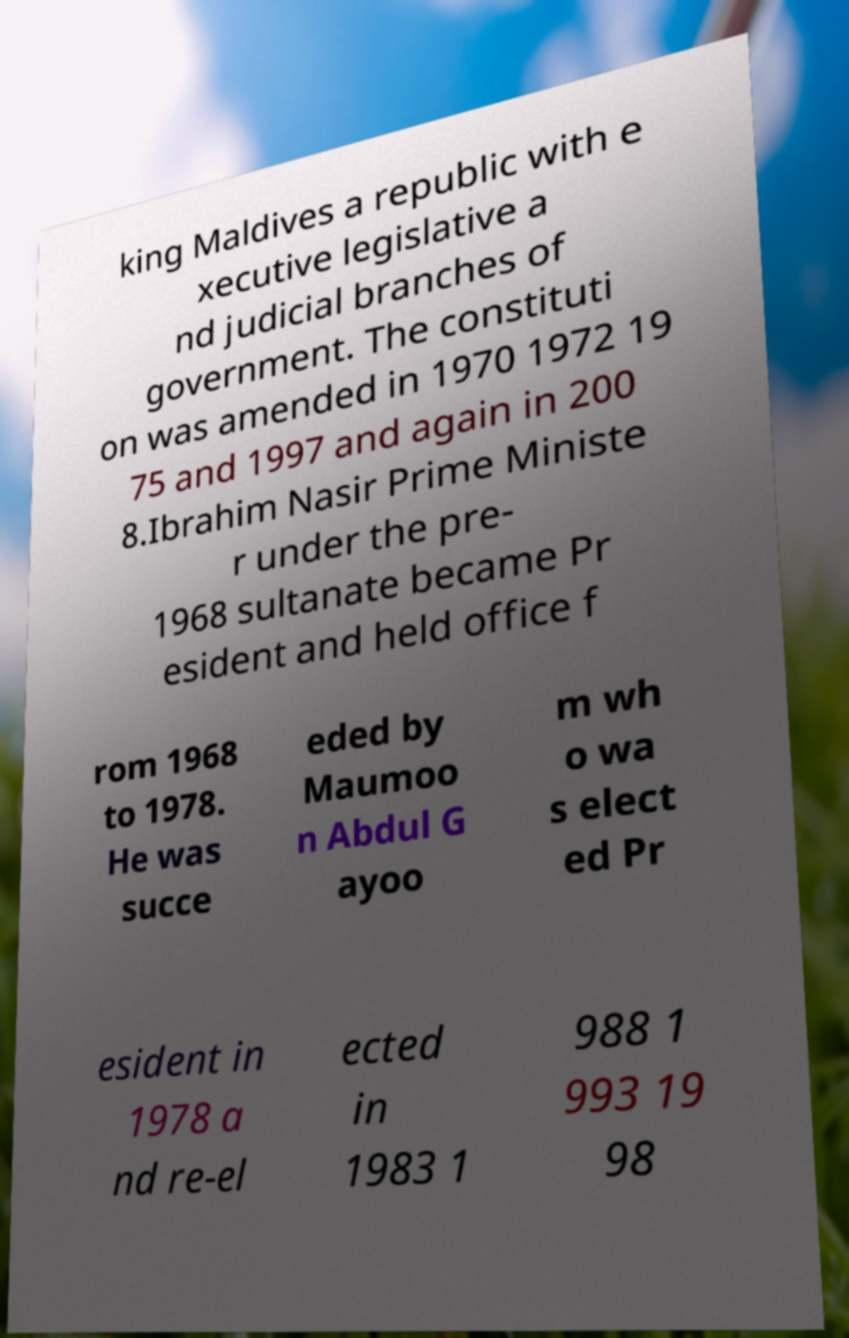What messages or text are displayed in this image? I need them in a readable, typed format. king Maldives a republic with e xecutive legislative a nd judicial branches of government. The constituti on was amended in 1970 1972 19 75 and 1997 and again in 200 8.Ibrahim Nasir Prime Ministe r under the pre- 1968 sultanate became Pr esident and held office f rom 1968 to 1978. He was succe eded by Maumoo n Abdul G ayoo m wh o wa s elect ed Pr esident in 1978 a nd re-el ected in 1983 1 988 1 993 19 98 